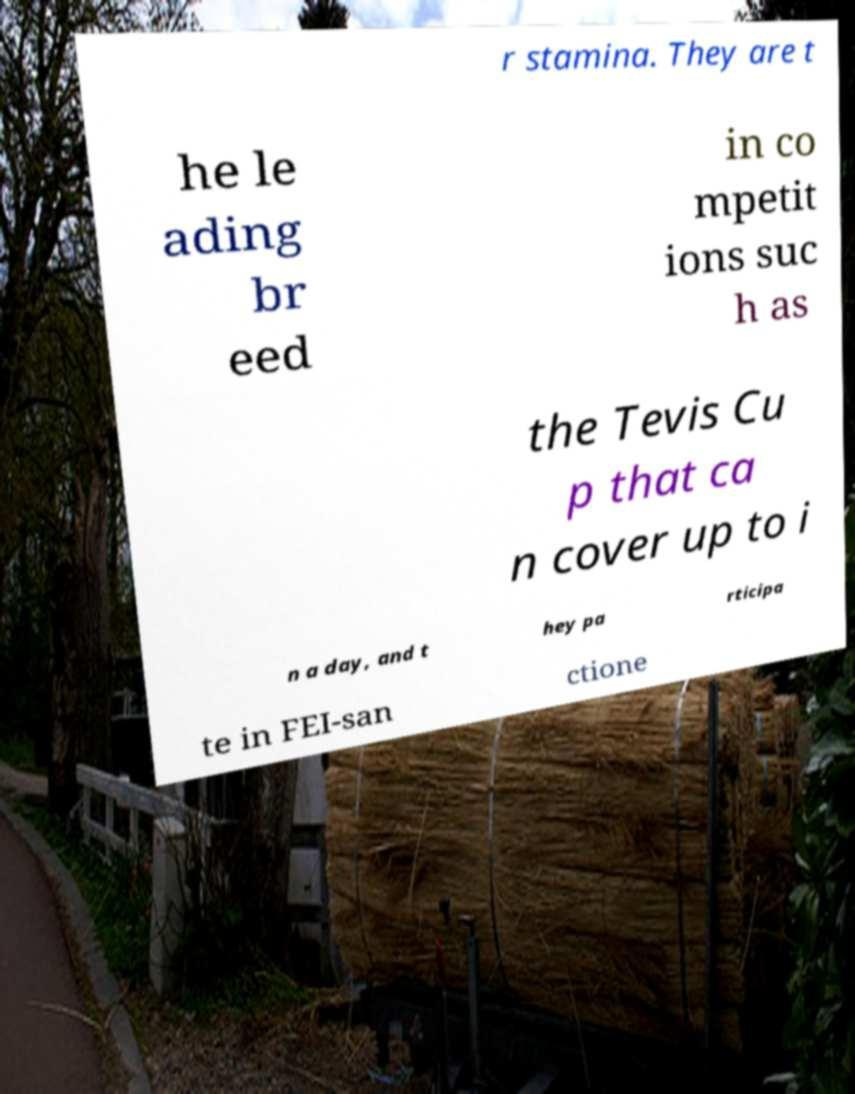For documentation purposes, I need the text within this image transcribed. Could you provide that? r stamina. They are t he le ading br eed in co mpetit ions suc h as the Tevis Cu p that ca n cover up to i n a day, and t hey pa rticipa te in FEI-san ctione 